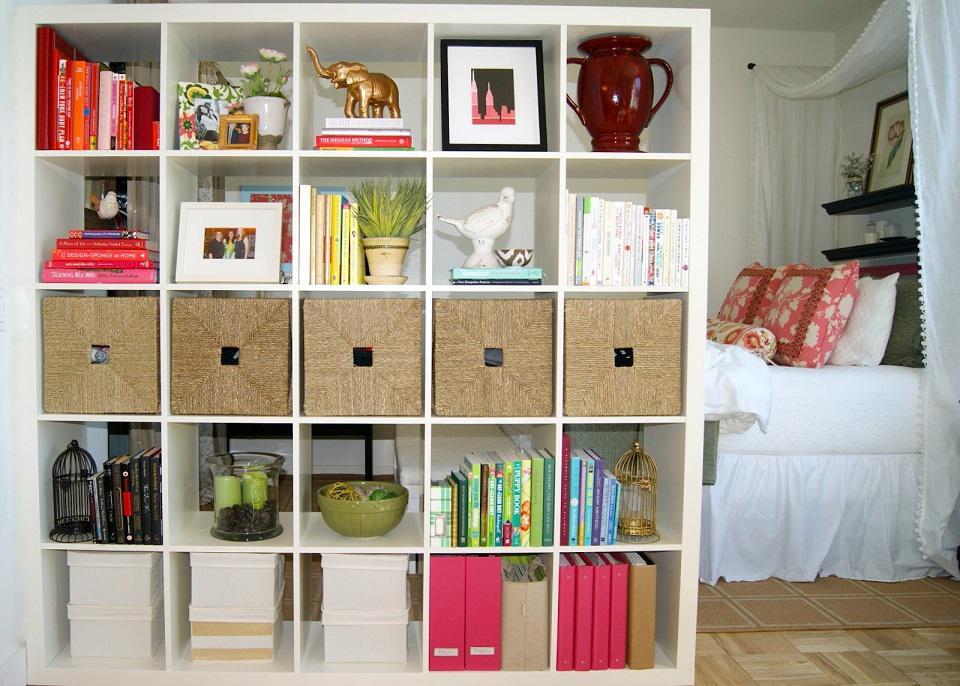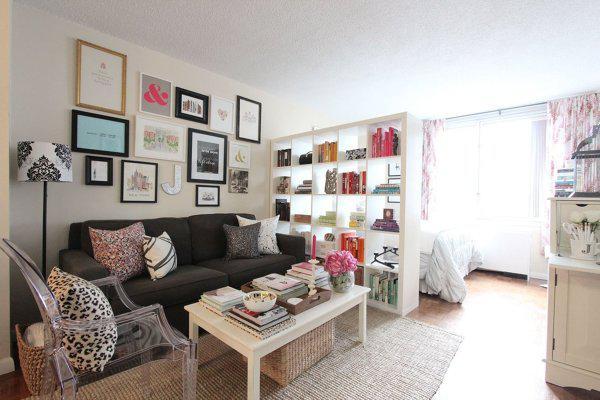The first image is the image on the left, the second image is the image on the right. Evaluate the accuracy of this statement regarding the images: "Some of the shelving is white and a vase of pink flowers is on a sofa coffee table in one of the images.". Is it true? Answer yes or no. Yes. The first image is the image on the left, the second image is the image on the right. Examine the images to the left and right. Is the description "One image has a coffee table and couch in front of a book case." accurate? Answer yes or no. Yes. 